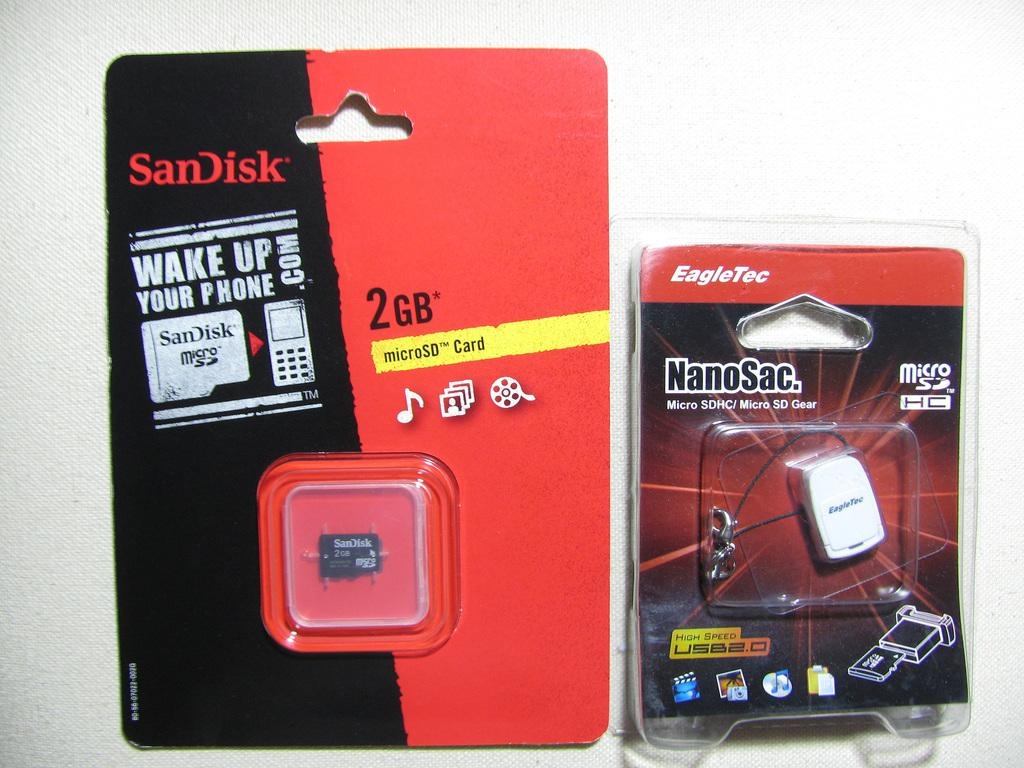<image>
Offer a succinct explanation of the picture presented. A red and black packaging of a 2GB microSD card 